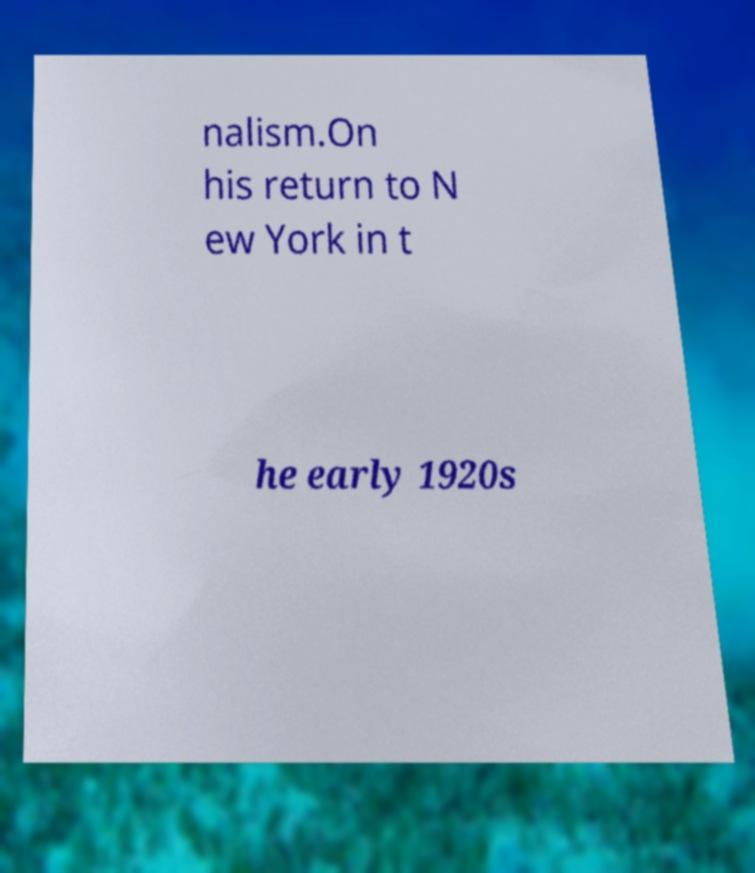Please read and relay the text visible in this image. What does it say? nalism.On his return to N ew York in t he early 1920s 